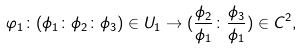Convert formula to latex. <formula><loc_0><loc_0><loc_500><loc_500>\varphi _ { 1 } \colon ( \phi _ { 1 } \colon \phi _ { 2 } \colon \phi _ { 3 } ) \in U _ { 1 } \rightarrow ( \frac { \phi _ { 2 } } { \phi _ { 1 } } \colon \frac { \phi _ { 3 } } { \phi _ { 1 } } ) \in C ^ { 2 } ,</formula> 